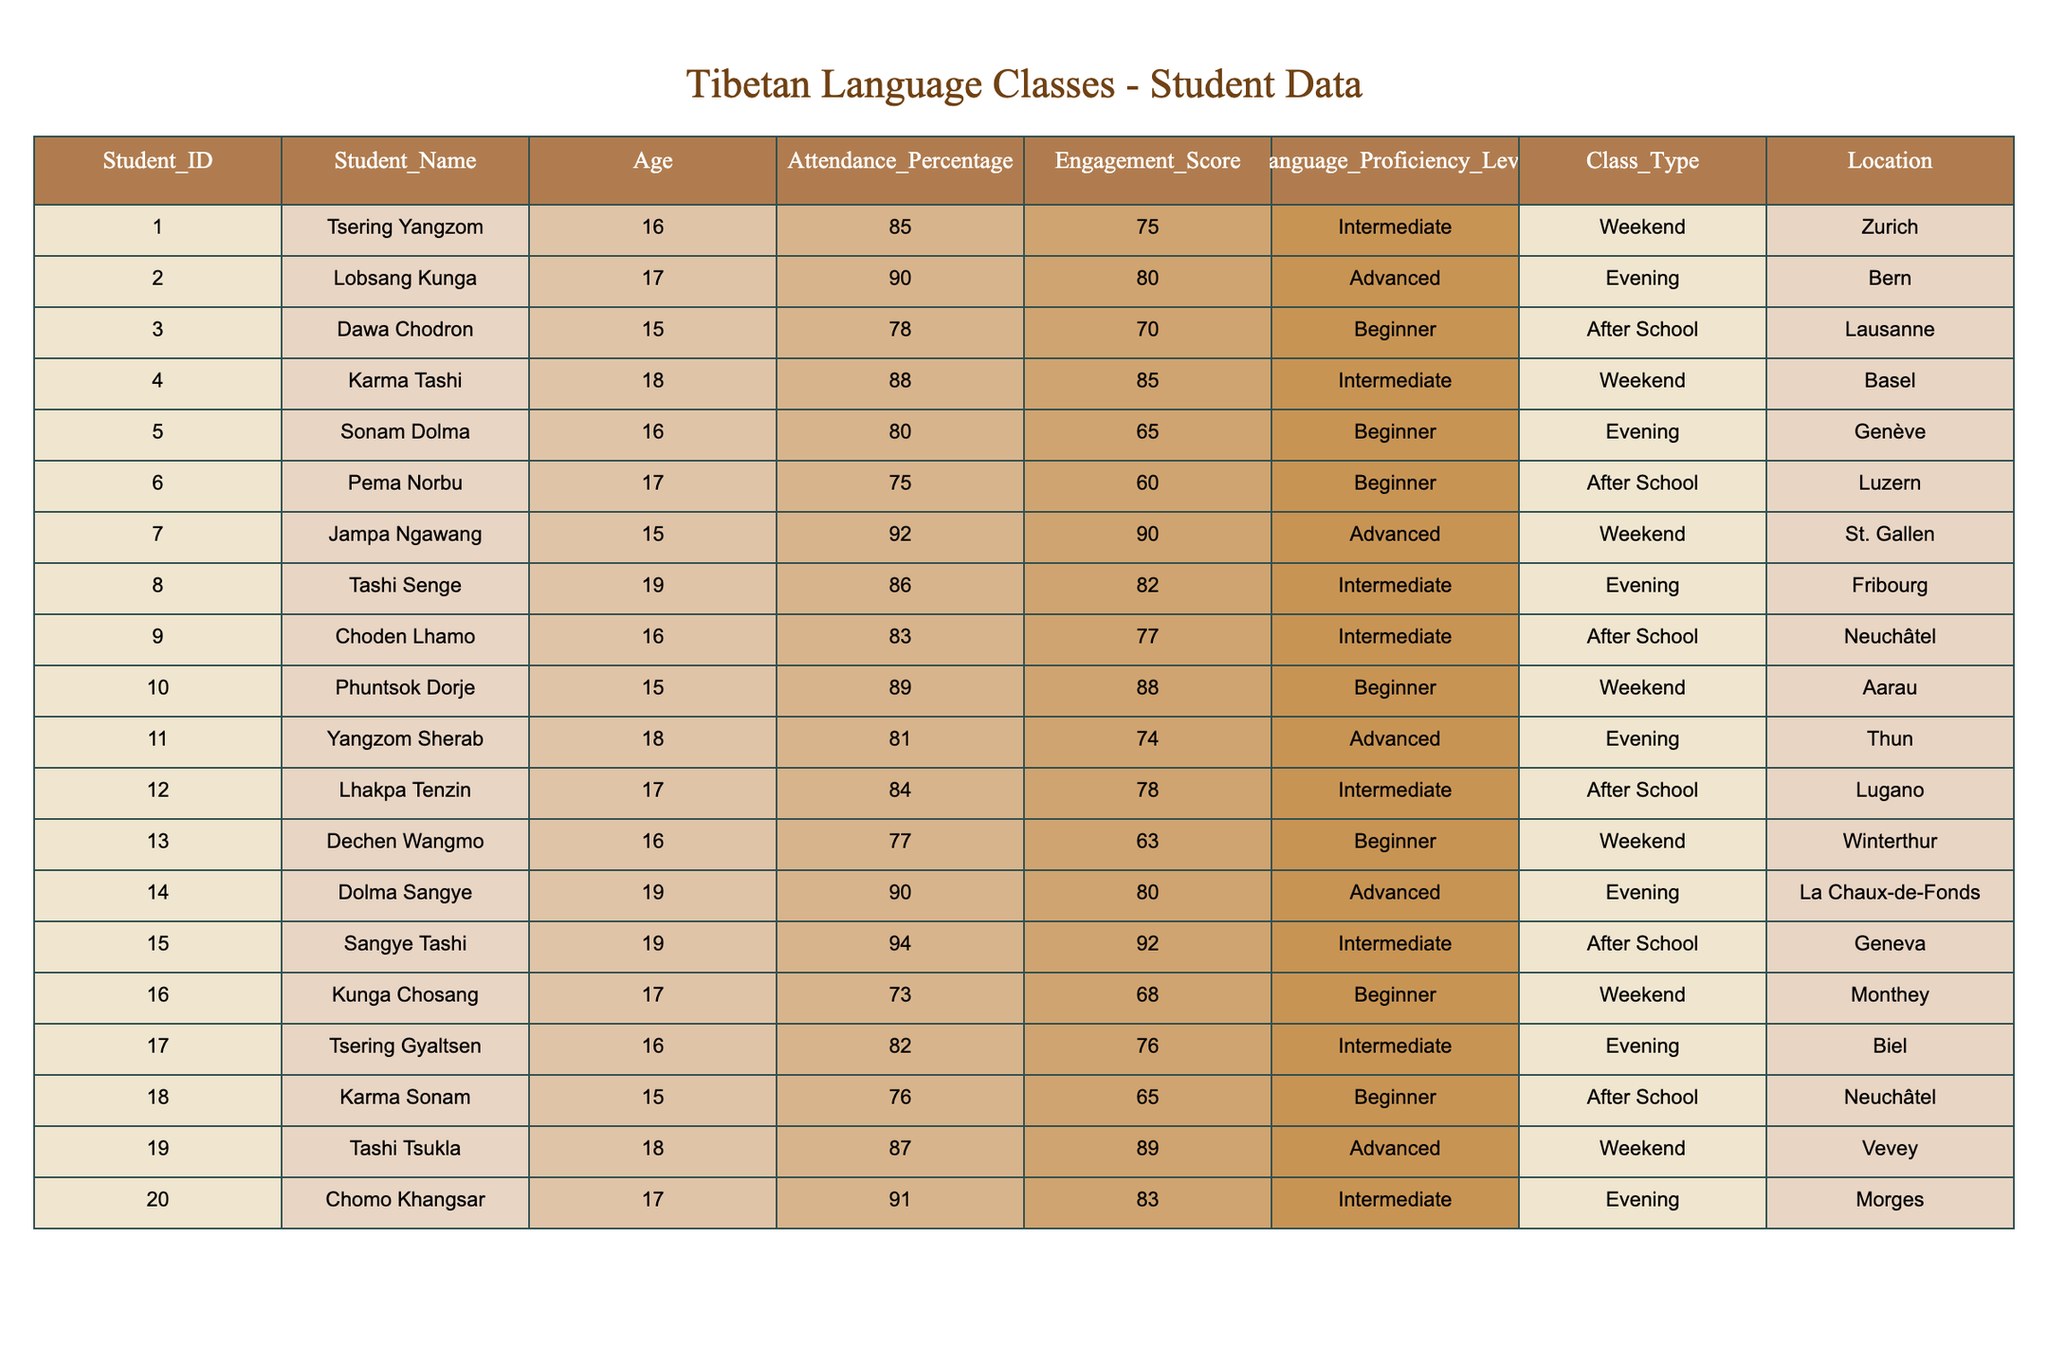What is the attendance percentage of Tsering Yangzom? The attendance percentage is listed directly under Tsering Yangzom’s entry in the table, which is 85.
Answer: 85 Which student has the highest engagement score? By reviewing the engagement scores in the table, I identify the highest score of 92 belongs to Sangye Tashi.
Answer: Sangye Tashi Is the language proficiency level of Phuntsok Dorje Beginner? The table indicates that Phuntsok Dorje’s language proficiency level is Beginner, confirming the statement as true.
Answer: Yes What is the average attendance percentage for students in the Beginner level? The attendance percentages for Begginer level students are 78, 80, 75, 77, and 76. Summing these gives 386 and dividing by 5 provides an average of 77.2.
Answer: 77.2 Which location has the highest percentage attendance among the students? Comparing the attendance percentages of each location, I find St. Gallen has the highest attendance percentage at 92.
Answer: St. Gallen How many students have an engagement score above 80? I go through the engagement scores and count the students with scores higher than 80 which are Jampa Ngawang, Tashi Tsukla, Chomo Khangsar, and Sangye Tashi, totaling 4 students.
Answer: 4 Do all students from Neuchâtel have an Intermediate language proficiency level? Checking both Neuchâtel entries, Choden Lhamo has Intermediate level while Karma Sonam has Beginner level, making the statement false.
Answer: No What is the difference in attendance percentage between the highest and lowest attending students? Jampa Ngawang has the highest attendance at 92%, and Kunga Chosang has the lowest at 73%. The difference is 92 - 73 = 19.
Answer: 19 How many students are categorized as Advanced? By scanning the table, I identify that there are 5 students classified as Advanced: Lobsang Kunga, Jampa Ngawang, Yangzom Sherab, Dolma Sangye, and Tashi Tsukla.
Answer: 5 